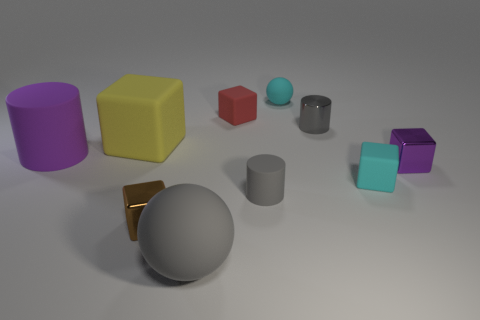Subtract all big yellow matte cubes. How many cubes are left? 4 Subtract all cyan cubes. How many cubes are left? 4 Subtract 2 blocks. How many blocks are left? 3 Subtract all gray cubes. Subtract all purple cylinders. How many cubes are left? 5 Subtract all cylinders. How many objects are left? 7 Add 2 green cubes. How many green cubes exist? 2 Subtract 0 yellow balls. How many objects are left? 10 Subtract all large rubber blocks. Subtract all tiny brown metal blocks. How many objects are left? 8 Add 1 tiny matte cylinders. How many tiny matte cylinders are left? 2 